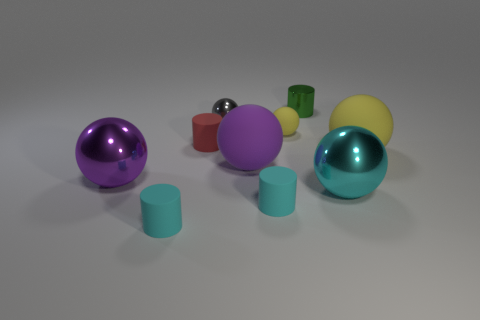There is a object that is both behind the small red object and on the right side of the small matte ball; what color is it? The object situated behind the small red object and to the right side of the small matte ball is green in color. It has a reflective surface similar to the nearby balls, which contrasts with the matte textures of some other objects in the scene. 